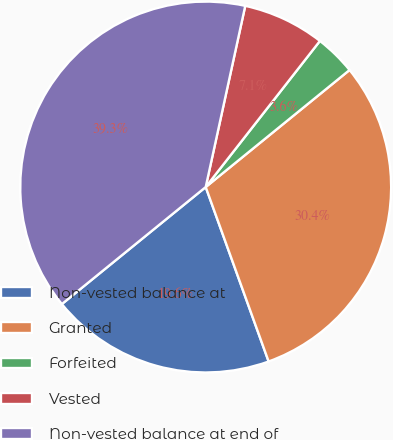Convert chart. <chart><loc_0><loc_0><loc_500><loc_500><pie_chart><fcel>Non-vested balance at<fcel>Granted<fcel>Forfeited<fcel>Vested<fcel>Non-vested balance at end of<nl><fcel>19.64%<fcel>30.36%<fcel>3.57%<fcel>7.14%<fcel>39.29%<nl></chart> 